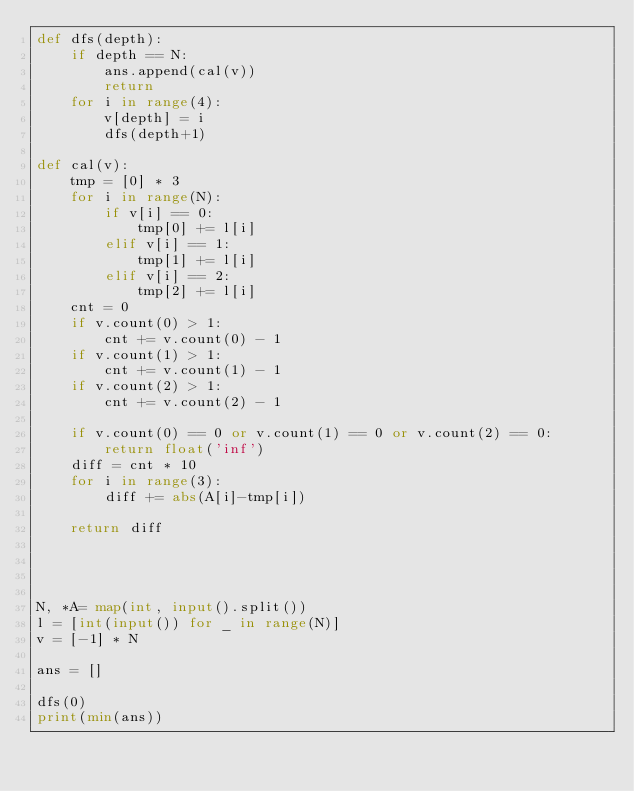<code> <loc_0><loc_0><loc_500><loc_500><_Python_>def dfs(depth):
    if depth == N:
        ans.append(cal(v))
        return
    for i in range(4):
        v[depth] = i
        dfs(depth+1) 

def cal(v):
    tmp = [0] * 3 
    for i in range(N):
        if v[i] == 0:
            tmp[0] += l[i]
        elif v[i] == 1:
            tmp[1] += l[i]
        elif v[i] == 2:
            tmp[2] += l[i]
    cnt = 0
    if v.count(0) > 1:
        cnt += v.count(0) - 1
    if v.count(1) > 1:
        cnt += v.count(1) - 1
    if v.count(2) > 1:
        cnt += v.count(2) - 1

    if v.count(0) == 0 or v.count(1) == 0 or v.count(2) == 0:
        return float('inf')
    diff = cnt * 10
    for i in range(3):
        diff += abs(A[i]-tmp[i])
    
    return diff
        
    
    

N, *A= map(int, input().split())
l = [int(input()) for _ in range(N)]
v = [-1] * N

ans = []

dfs(0)
print(min(ans))</code> 